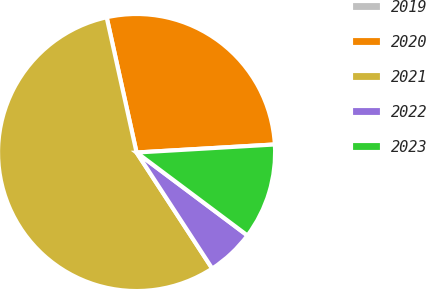Convert chart. <chart><loc_0><loc_0><loc_500><loc_500><pie_chart><fcel>2019<fcel>2020<fcel>2021<fcel>2022<fcel>2023<nl><fcel>0.0%<fcel>27.54%<fcel>55.73%<fcel>5.58%<fcel>11.15%<nl></chart> 